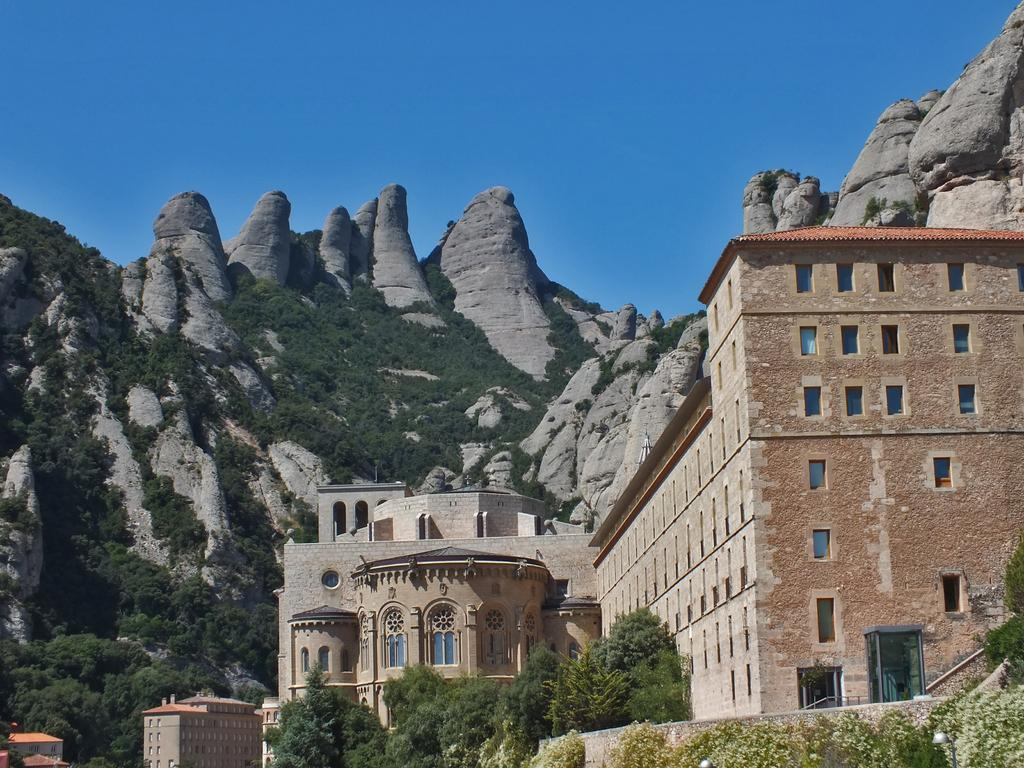What type of structures can be seen in the image? There are buildings in the image. What natural elements are present in the image? There are trees and mountains in the image. What architectural features can be observed in the image? There are windows and a wall visible in the image. What additional details can be seen in the image? There are flowers in the image. What part of the natural environment is visible in the background of the image? The sky is visible in the background of the image. How many clovers are growing in the image? There are no clovers present in the image. What type of writing instrument is being used by the mountains in the image? There are no writing instruments present in the image, as mountains are natural formations and do not use writing instruments. 